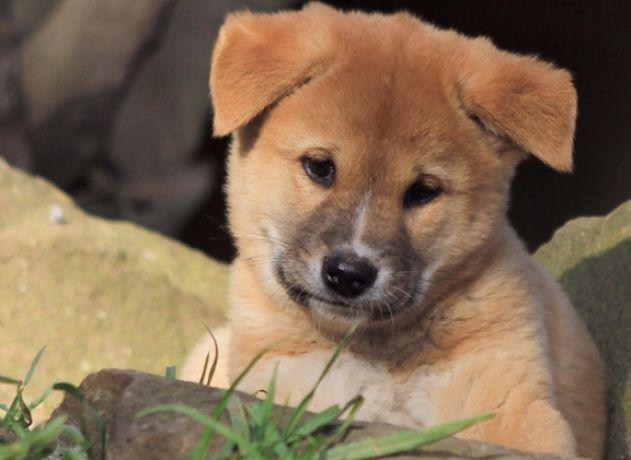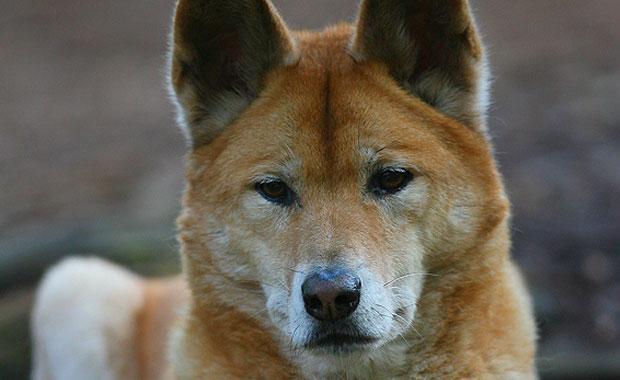The first image is the image on the left, the second image is the image on the right. Evaluate the accuracy of this statement regarding the images: "There are two dogs in the pair of images.". Is it true? Answer yes or no. Yes. The first image is the image on the left, the second image is the image on the right. Assess this claim about the two images: "Each image contains exactly one dingo, and no dog looks levelly at the camera.". Correct or not? Answer yes or no. Yes. 